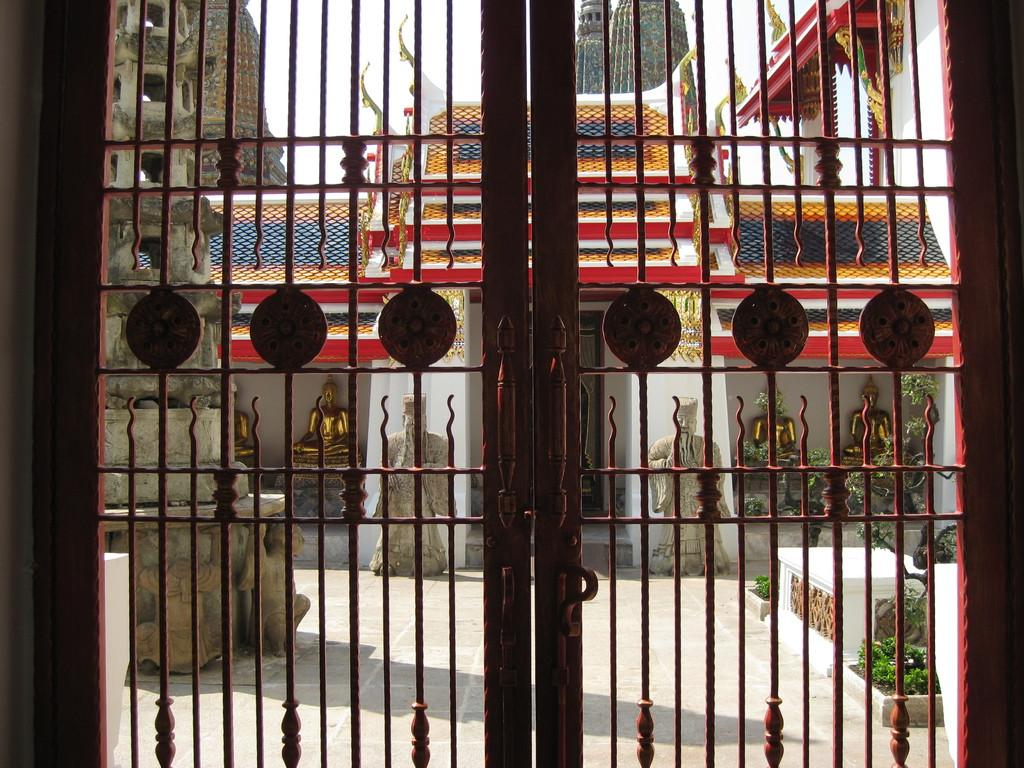What type of structure is shown in the image? The image appears to depict a temple. Is the temple open or closed? The temple is closed. What can be seen behind the doors of the temple? There are sculptures behind the doors of the temple. What decorative elements are present on the walls of the temple? Carvings are done on the walls of the temple. How many brothers are depicted in the carvings on the walls of the temple? There is no information about brothers in the carvings on the walls of the temple; the facts only mention that there are carvings on the walls. 